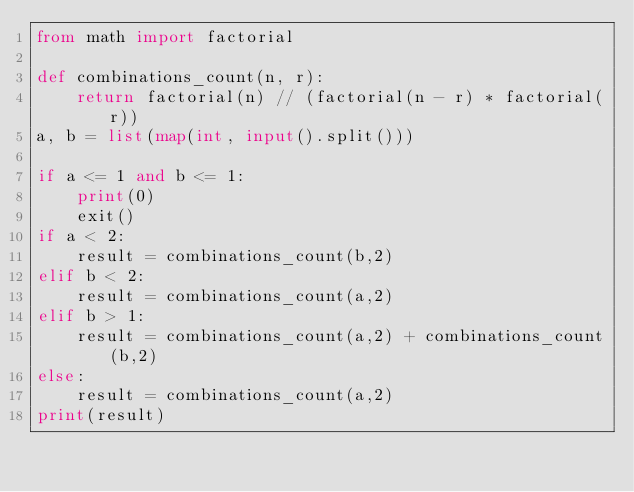Convert code to text. <code><loc_0><loc_0><loc_500><loc_500><_Python_>from math import factorial

def combinations_count(n, r):
    return factorial(n) // (factorial(n - r) * factorial(r))
a, b = list(map(int, input().split()))

if a <= 1 and b <= 1:
    print(0)
    exit()
if a < 2:
    result = combinations_count(b,2)
elif b < 2:
    result = combinations_count(a,2)
elif b > 1:
    result = combinations_count(a,2) + combinations_count(b,2)
else:
    result = combinations_count(a,2)
print(result)
</code> 